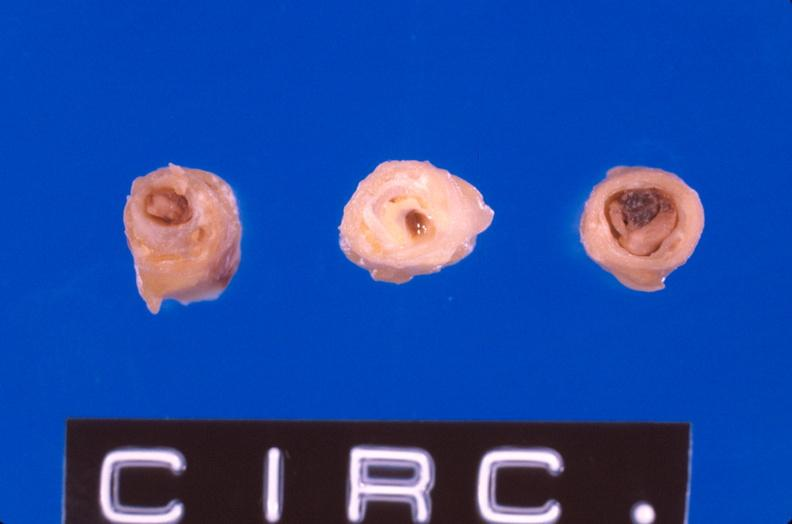s vasculature present?
Answer the question using a single word or phrase. Yes 